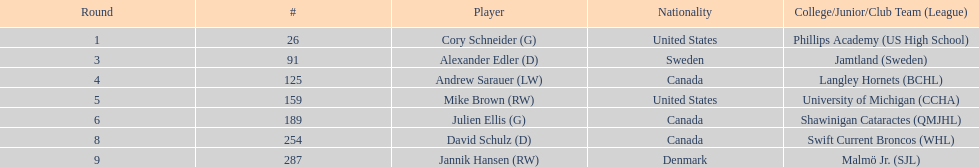What's the count of goalkeepers that were drafted? 2. 